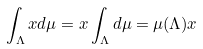Convert formula to latex. <formula><loc_0><loc_0><loc_500><loc_500>\int _ { \Lambda } x d \mu = x \int _ { \Lambda } d \mu = \mu ( \Lambda ) x</formula> 